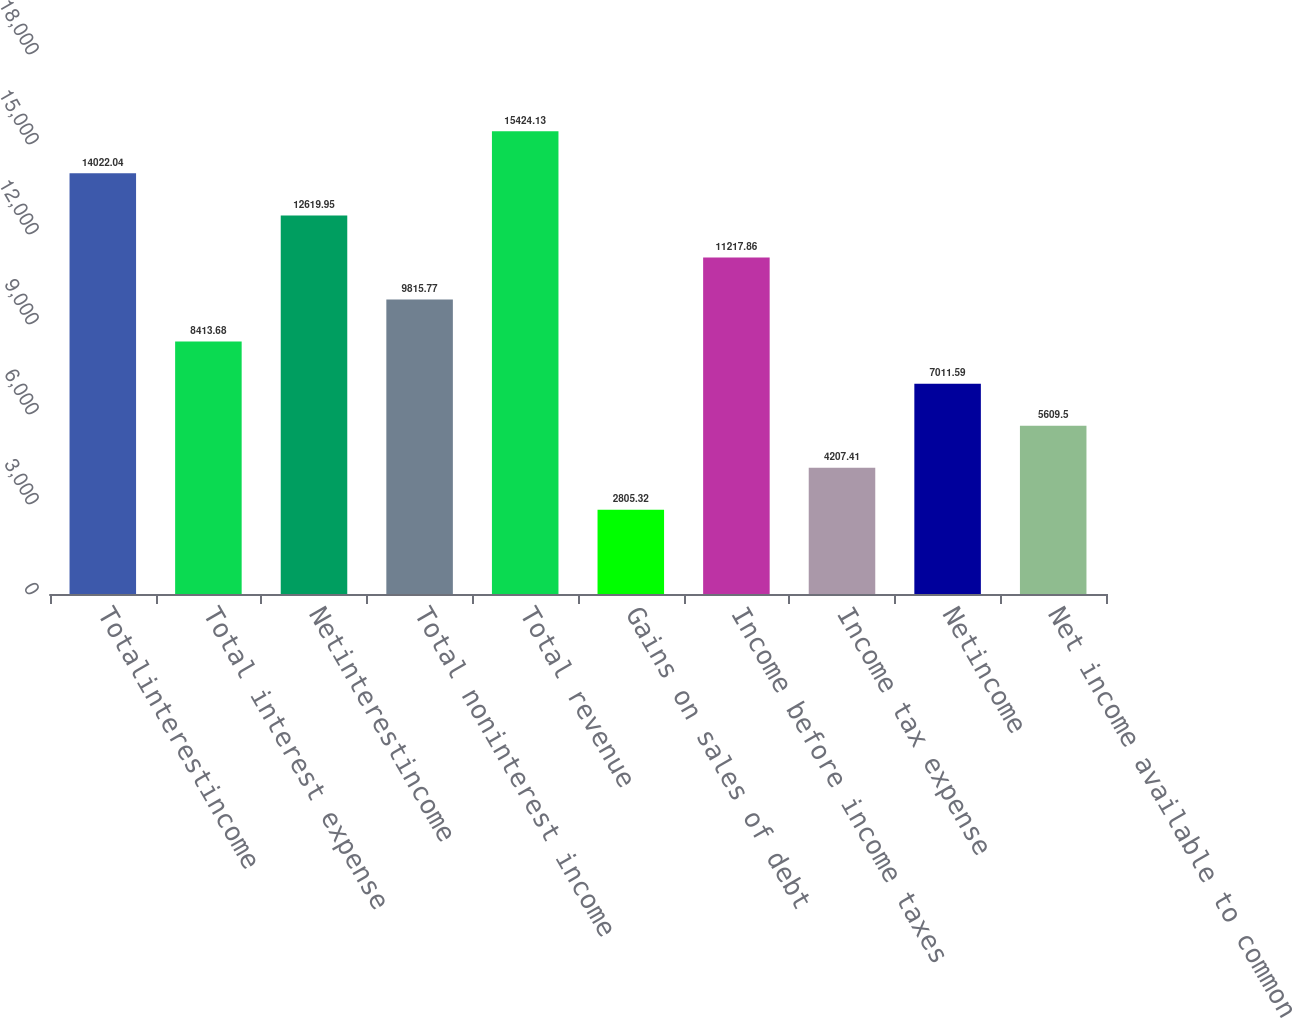Convert chart to OTSL. <chart><loc_0><loc_0><loc_500><loc_500><bar_chart><fcel>Totalinterestincome<fcel>Total interest expense<fcel>Netinterestincome<fcel>Total noninterest income<fcel>Total revenue<fcel>Gains on sales of debt<fcel>Income before income taxes<fcel>Income tax expense<fcel>Netincome<fcel>Net income available to common<nl><fcel>14022<fcel>8413.68<fcel>12620<fcel>9815.77<fcel>15424.1<fcel>2805.32<fcel>11217.9<fcel>4207.41<fcel>7011.59<fcel>5609.5<nl></chart> 